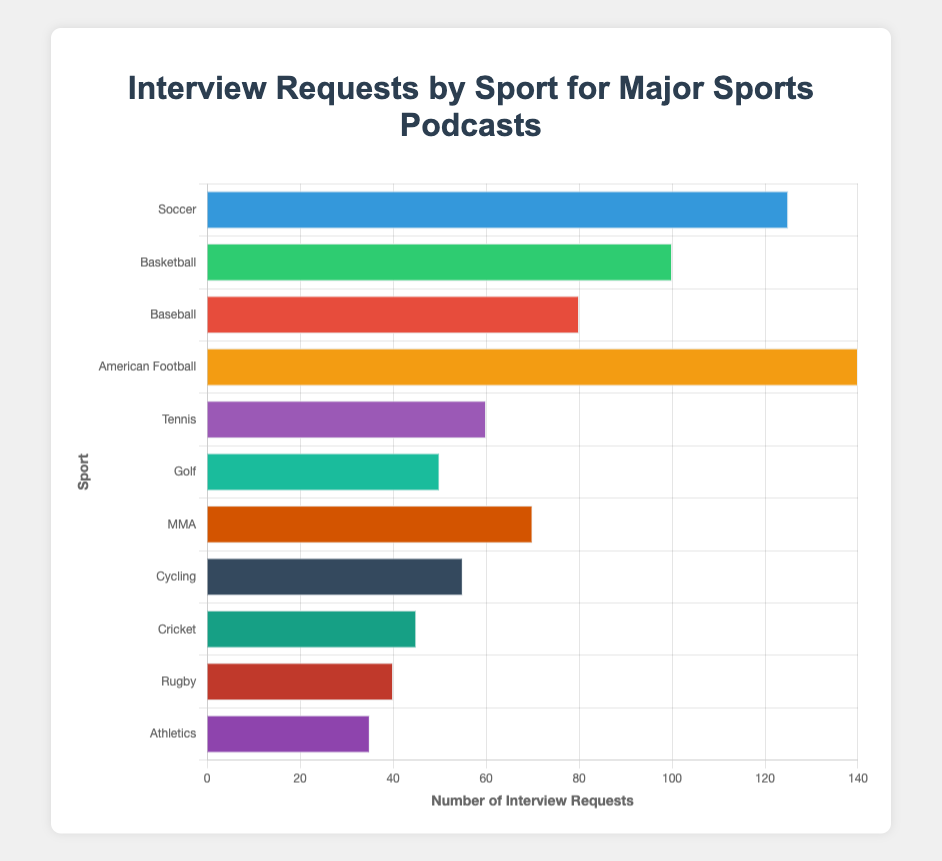Which sport received the most interview requests? "American Football" has the highest bar in the chart, indicating it received the most interview requests.
Answer: American Football Which sport received fewer interview requests, Tennis or MMA? The bar for Tennis is shorter than the bar for MMA, meaning Tennis received fewer interview requests than MMA.
Answer: Tennis What is the total number of interview requests for Soccer and Basketball combined? Soccer received 125 requests and Basketball received 100 requests. Adding these, 125 + 100 = 225
Answer: 225 How many more interview requests did Soccer receive than Baseball? Soccer received 125 requests and Baseball received 80 requests. The difference is 125 - 80 = 45
Answer: 45 Which sport has a bar color of red? The bar representing Baseball has the color red, indicating this sport.
Answer: Baseball How many interview requests did the second most popular sport receive? The second most popular sport by interview requests is Soccer with 125 requests.
Answer: 125 What’s the average number of interview requests among Golf, Rugby, and Athletics? Golf received 50 requests, Rugby received 40, and Athletics received 35. The sum is 50 + 40 + 35 = 125. The average is 125 / 3 ≈ 41.67
Answer: 41.67 Which sport received the least number of interview requests? The sport with the lowest bar length is Athletics, indicating it received the least interview requests, 35.
Answer: Athletics 